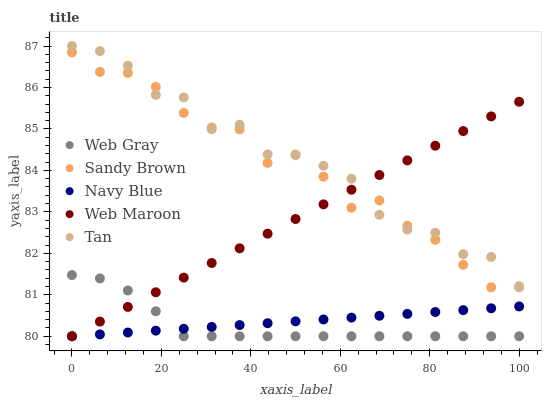Does Web Gray have the minimum area under the curve?
Answer yes or no. Yes. Does Tan have the maximum area under the curve?
Answer yes or no. Yes. Does Tan have the minimum area under the curve?
Answer yes or no. No. Does Web Gray have the maximum area under the curve?
Answer yes or no. No. Is Navy Blue the smoothest?
Answer yes or no. Yes. Is Tan the roughest?
Answer yes or no. Yes. Is Web Gray the smoothest?
Answer yes or no. No. Is Web Gray the roughest?
Answer yes or no. No. Does Navy Blue have the lowest value?
Answer yes or no. Yes. Does Tan have the lowest value?
Answer yes or no. No. Does Tan have the highest value?
Answer yes or no. Yes. Does Web Gray have the highest value?
Answer yes or no. No. Is Web Gray less than Sandy Brown?
Answer yes or no. Yes. Is Sandy Brown greater than Web Gray?
Answer yes or no. Yes. Does Web Maroon intersect Navy Blue?
Answer yes or no. Yes. Is Web Maroon less than Navy Blue?
Answer yes or no. No. Is Web Maroon greater than Navy Blue?
Answer yes or no. No. Does Web Gray intersect Sandy Brown?
Answer yes or no. No. 